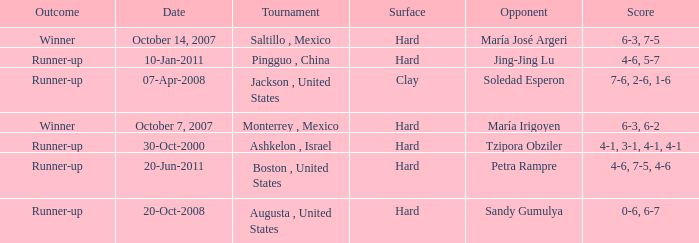Which tournament was held on October 14, 2007? Saltillo , Mexico. Help me parse the entirety of this table. {'header': ['Outcome', 'Date', 'Tournament', 'Surface', 'Opponent', 'Score'], 'rows': [['Winner', 'October 14, 2007', 'Saltillo , Mexico', 'Hard', 'María José Argeri', '6-3, 7-5'], ['Runner-up', '10-Jan-2011', 'Pingguo , China', 'Hard', 'Jing-Jing Lu', '4-6, 5-7'], ['Runner-up', '07-Apr-2008', 'Jackson , United States', 'Clay', 'Soledad Esperon', '7-6, 2-6, 1-6'], ['Winner', 'October 7, 2007', 'Monterrey , Mexico', 'Hard', 'María Irigoyen', '6-3, 6-2'], ['Runner-up', '30-Oct-2000', 'Ashkelon , Israel', 'Hard', 'Tzipora Obziler', '4-1, 3-1, 4-1, 4-1'], ['Runner-up', '20-Jun-2011', 'Boston , United States', 'Hard', 'Petra Rampre', '4-6, 7-5, 4-6'], ['Runner-up', '20-Oct-2008', 'Augusta , United States', 'Hard', 'Sandy Gumulya', '0-6, 6-7']]} 